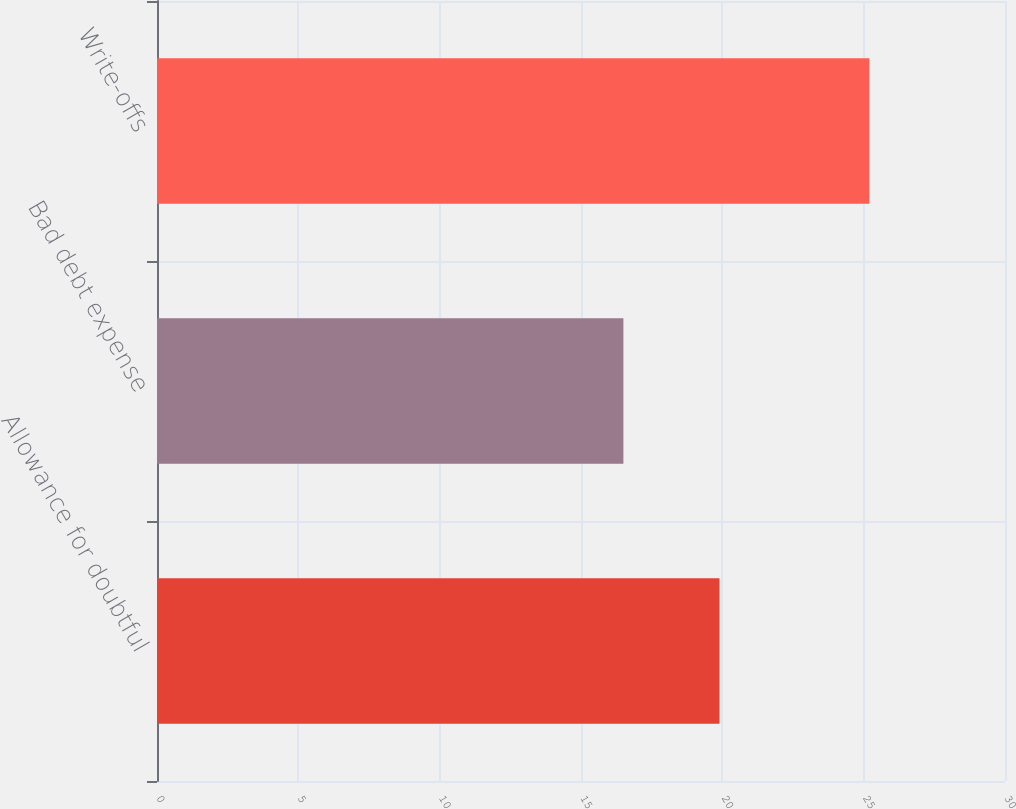Convert chart. <chart><loc_0><loc_0><loc_500><loc_500><bar_chart><fcel>Allowance for doubtful<fcel>Bad debt expense<fcel>Write-offs<nl><fcel>19.9<fcel>16.5<fcel>25.2<nl></chart> 